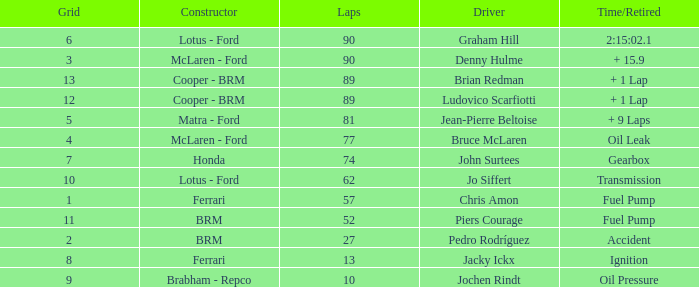What is the time/retired when the laps is 52? Fuel Pump. 